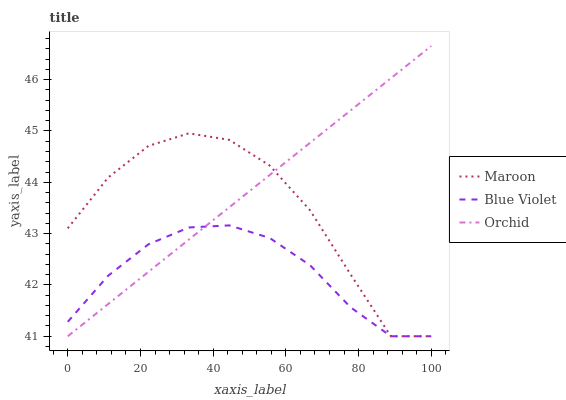Does Blue Violet have the minimum area under the curve?
Answer yes or no. Yes. Does Orchid have the maximum area under the curve?
Answer yes or no. Yes. Does Maroon have the minimum area under the curve?
Answer yes or no. No. Does Maroon have the maximum area under the curve?
Answer yes or no. No. Is Orchid the smoothest?
Answer yes or no. Yes. Is Maroon the roughest?
Answer yes or no. Yes. Is Maroon the smoothest?
Answer yes or no. No. Is Orchid the roughest?
Answer yes or no. No. Does Orchid have the highest value?
Answer yes or no. Yes. Does Maroon have the highest value?
Answer yes or no. No. Does Maroon intersect Blue Violet?
Answer yes or no. Yes. Is Maroon less than Blue Violet?
Answer yes or no. No. Is Maroon greater than Blue Violet?
Answer yes or no. No. 